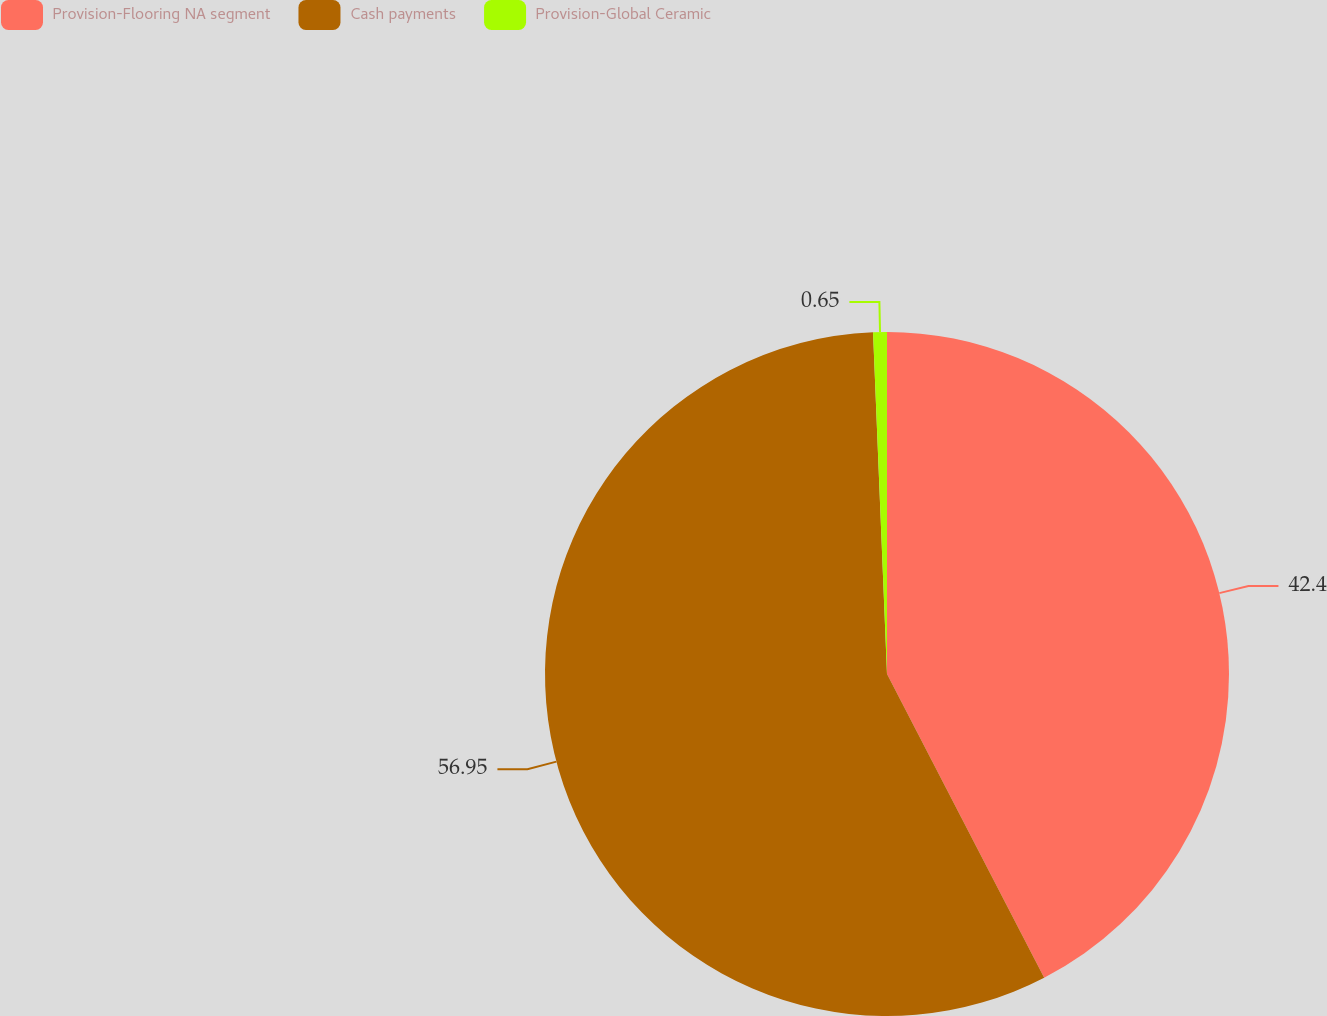<chart> <loc_0><loc_0><loc_500><loc_500><pie_chart><fcel>Provision-Flooring NA segment<fcel>Cash payments<fcel>Provision-Global Ceramic<nl><fcel>42.4%<fcel>56.95%<fcel>0.65%<nl></chart> 